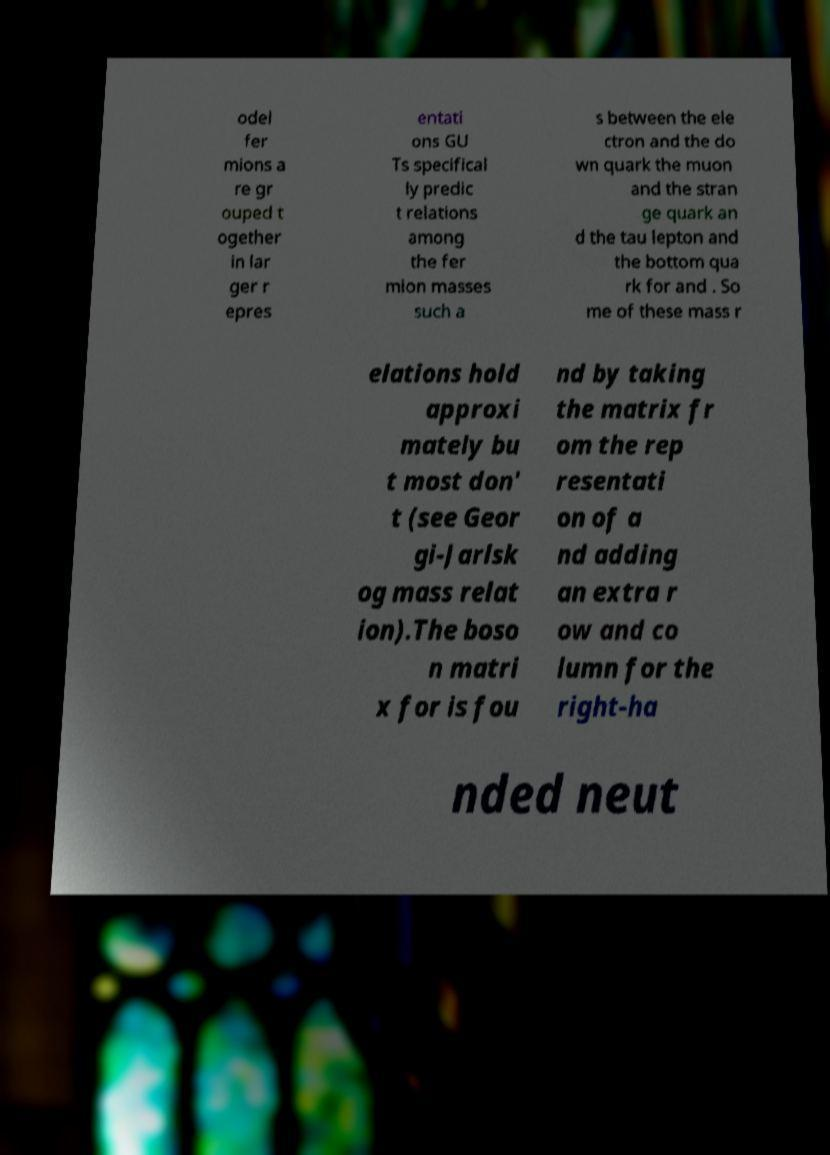Can you accurately transcribe the text from the provided image for me? odel fer mions a re gr ouped t ogether in lar ger r epres entati ons GU Ts specifical ly predic t relations among the fer mion masses such a s between the ele ctron and the do wn quark the muon and the stran ge quark an d the tau lepton and the bottom qua rk for and . So me of these mass r elations hold approxi mately bu t most don' t (see Geor gi-Jarlsk og mass relat ion).The boso n matri x for is fou nd by taking the matrix fr om the rep resentati on of a nd adding an extra r ow and co lumn for the right-ha nded neut 